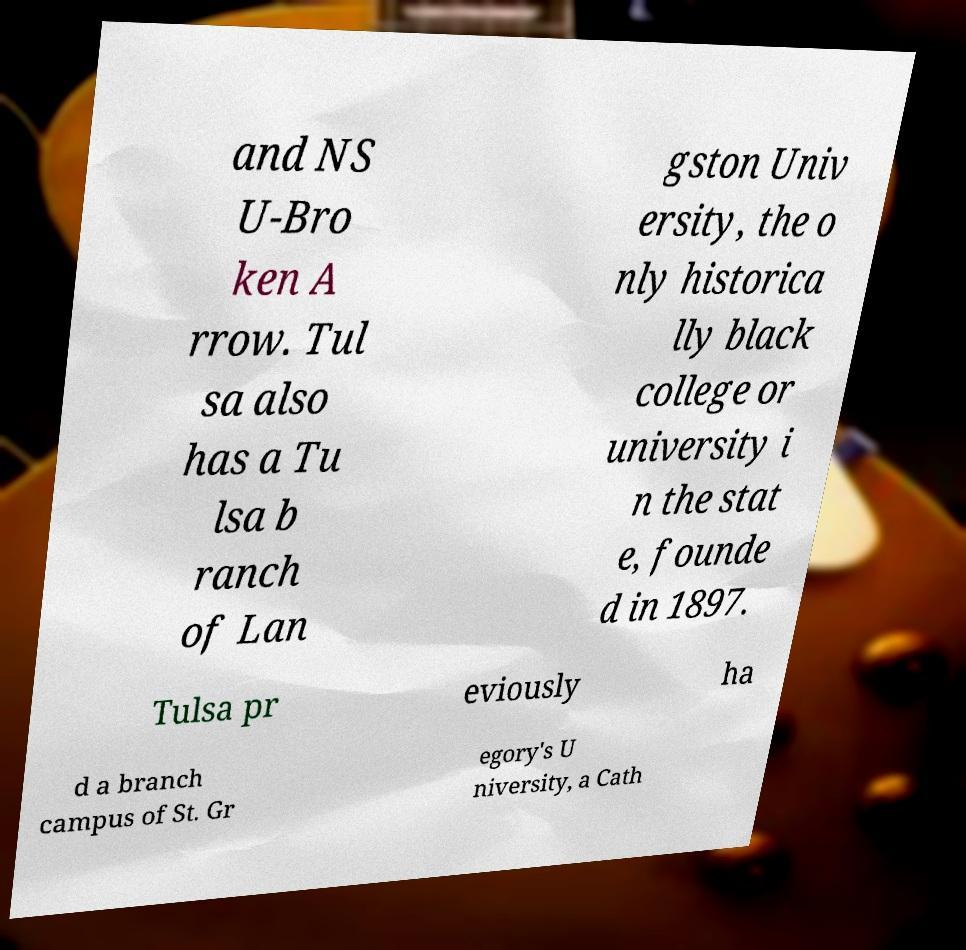There's text embedded in this image that I need extracted. Can you transcribe it verbatim? and NS U-Bro ken A rrow. Tul sa also has a Tu lsa b ranch of Lan gston Univ ersity, the o nly historica lly black college or university i n the stat e, founde d in 1897. Tulsa pr eviously ha d a branch campus of St. Gr egory's U niversity, a Cath 